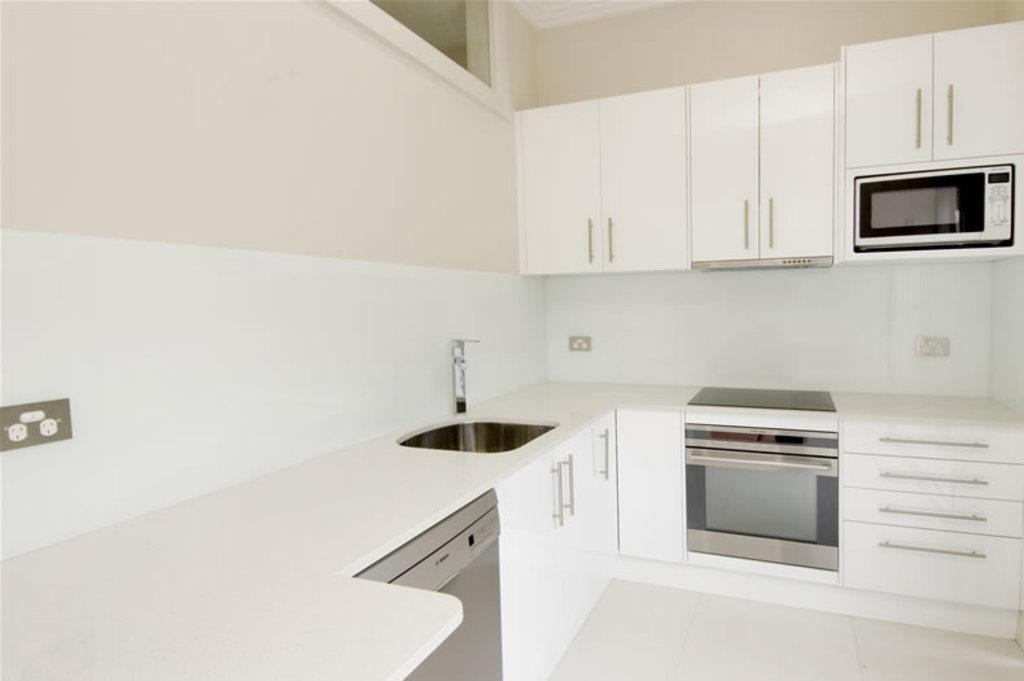What type of structure is present on the kitchen platform in the image? There is a wash basin with a tap on the platform in the image. What other feature can be seen on the platform? There are racks on the kitchen platform. What is located on the wall in the image? There is a cupboard on the wall in the image. What appliance is inside the cupboard? A microwave oven is present in the cupboard. Is there a church visible in the image? No, there is no church present in the image; it features a kitchen platform, wash basin, racks, cupboard, and microwave oven. 